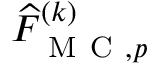<formula> <loc_0><loc_0><loc_500><loc_500>\widehat { F } _ { M C , p } ^ { ( k ) }</formula> 